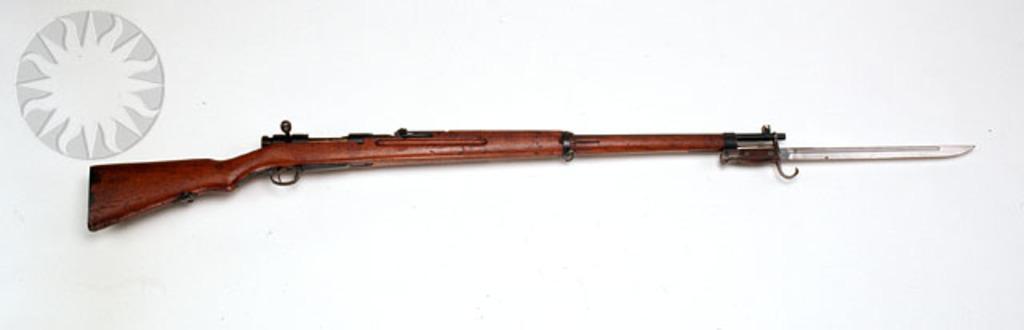Can you describe this image briefly? In this image I can see a gun which is brown and black in color on the white colored surface and I can see a knife to the right end of the gun. 